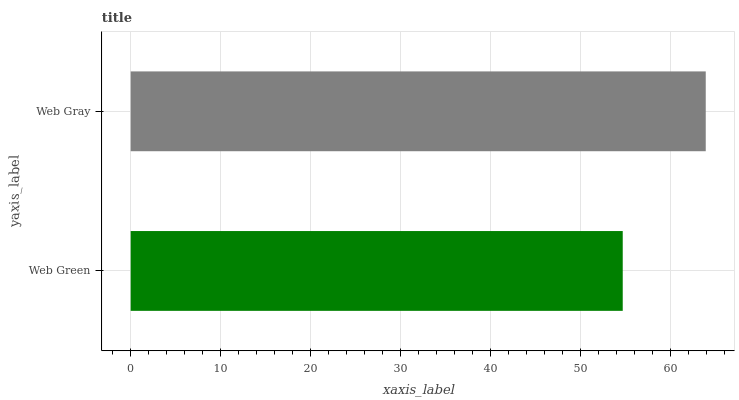Is Web Green the minimum?
Answer yes or no. Yes. Is Web Gray the maximum?
Answer yes or no. Yes. Is Web Gray the minimum?
Answer yes or no. No. Is Web Gray greater than Web Green?
Answer yes or no. Yes. Is Web Green less than Web Gray?
Answer yes or no. Yes. Is Web Green greater than Web Gray?
Answer yes or no. No. Is Web Gray less than Web Green?
Answer yes or no. No. Is Web Gray the high median?
Answer yes or no. Yes. Is Web Green the low median?
Answer yes or no. Yes. Is Web Green the high median?
Answer yes or no. No. Is Web Gray the low median?
Answer yes or no. No. 